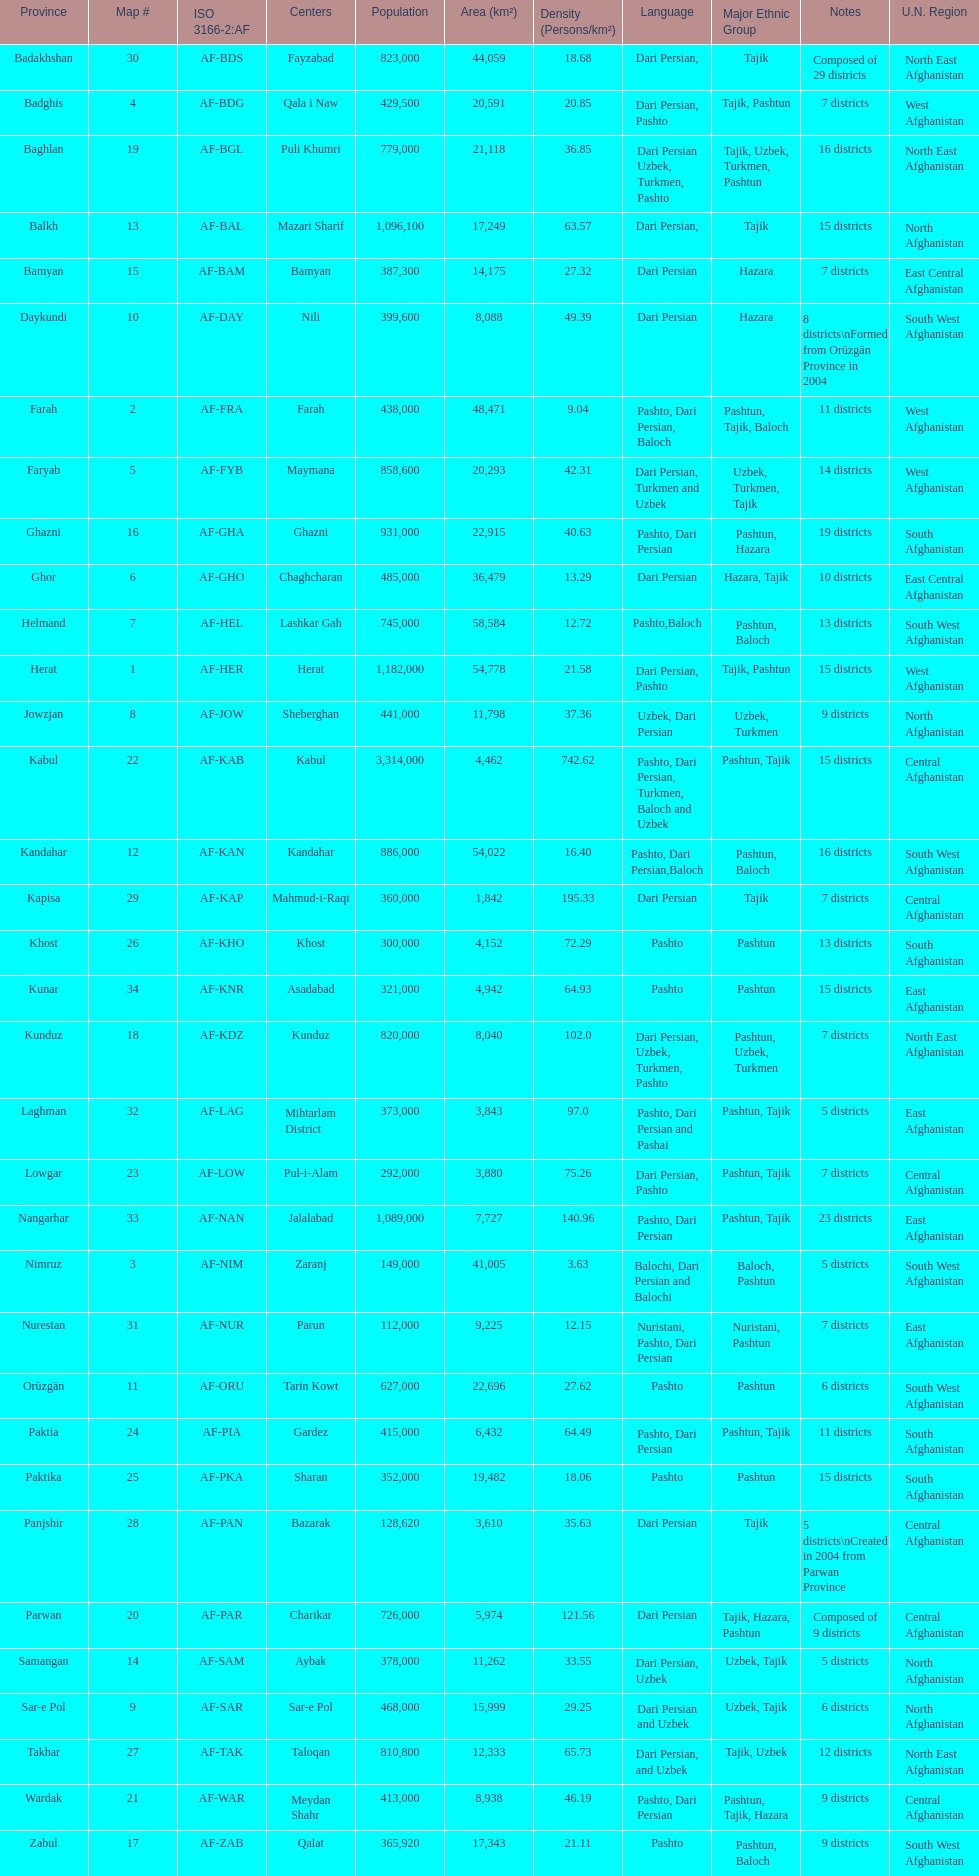How many provinces have the same number of districts as kabul? 4. 